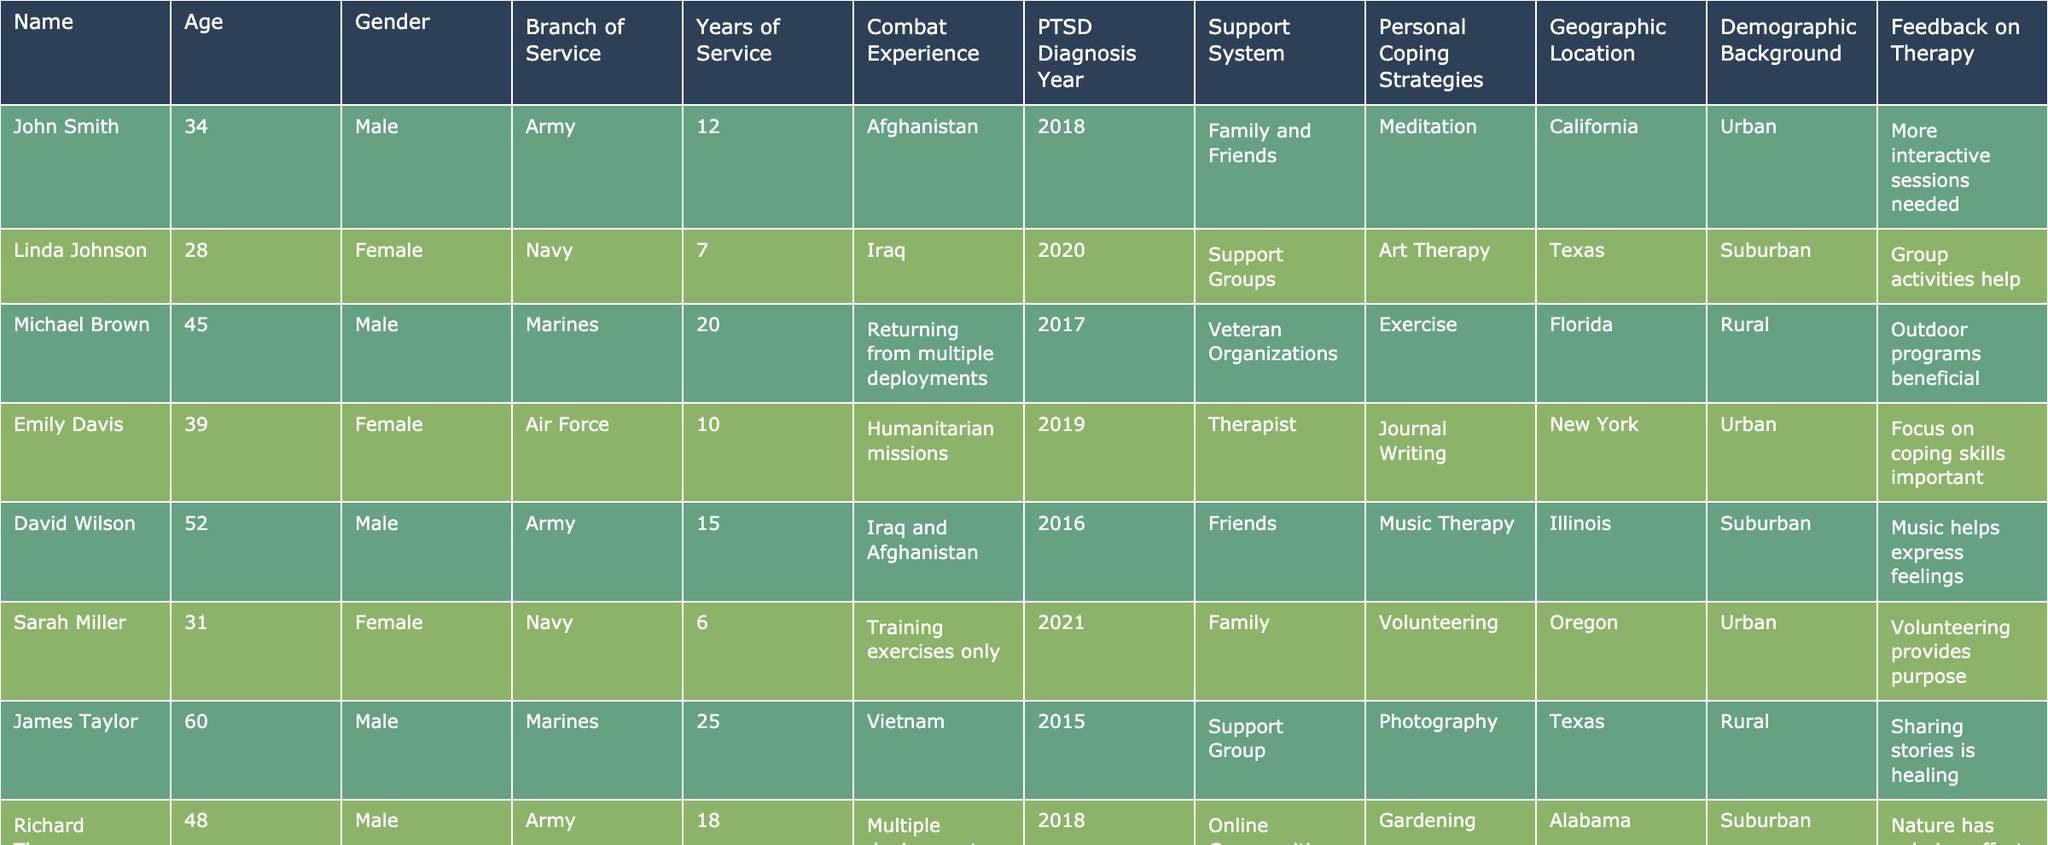What is the age of John Smith? John Smith's age is listed directly in the table under the "Age" column, which states he is 34 years old.
Answer: 34 How many years of service did Linda Johnson complete? Linda Johnson's years of service is found in the "Years of Service" column, which shows she served for 7 years.
Answer: 7 Which branch of service has the oldest average age represented in the table? The table will require examining the ages of veterans from each branch. The Army veterans' ages are 34, 52, and 48; the Navy veterans' ages are 28, 31, and 45; the Marines veterans' ages are 45, 60, and 30; and the Air Force veterans' age is 39. Calculating averages, Army: (34 + 52 + 48) / 3 = 44.67; Navy: (28 + 31 + 45) / 3 = 34.67; Marines: (45 + 60 + 30) / 3 = 45; Air Force: 39. The Army has the highest average age of 44.67.
Answer: Army What support system is associated with Thomas Harris? The table indicates Thomas Harris's support system in the "Support System" column as "Peer Support."
Answer: Peer Support Is there any female veteran who copes with PTSD through reading? Reviewing the "Personal Coping Strategies" column, Karen White, categorized as female, uses "Reading" as her coping strategy. Thus, there is a female veteran who copes with reading.
Answer: Yes Which demographic background has the highest representation of veterans in the table? The demographic backgrounds are Urban, Suburban, and Rural. Counting occurrences: Urban has 5, Suburban has 4, and Rural has 3, indicating Urban is the most frequent background.
Answer: Urban How many different personal coping strategies are listed in total across the table? By analyzing the "Personal Coping Strategies" column and listing them: Meditation, Art Therapy, Exercise, Journal Writing, Music Therapy, Volunteering, Photography, Gardening, Reading, Travel, Mindfulness, Physical Activity, Creative Writing. Counting these provides a total of 13 unique personal coping strategies.
Answer: 13 What percentage of veterans diagnosed with PTSD used a support system of family or friends? There are 13 veterans total, and 4 of them (John Smith, David Wilson, Sarah Miller, and Karen White) use family or friends for support. The percentage calculation is (4/13) * 100, which equals approximately 30.77%.
Answer: 30.77% How does the combat experience relate to the support system for veterans who served in the Army? Reviewing the Army veterans in the table (John Smith, David Wilson, Richard Thomas, and Thomas Harris), we find combat experience levels are Afghanistan, Iraq and Afghanistan, Multiple deployments, and Korean War. The support systems range from Family and Friends to Peer Support. Thus, soldiers have diverse support systems regardless of varying combat experiences.
Answer: Diverse support systems What unique feedback about therapy is given by veterans from rural demographics? Analyzing the feedback, Michael Brown and Joseph Clark, both from rural areas, emphasize beneficial outdoor programs and the importance of exercise, respectively. Their feedback shows a common theme related to nature and physical activity in handling therapy.
Answer: Nature and physical activity-focused feedback 